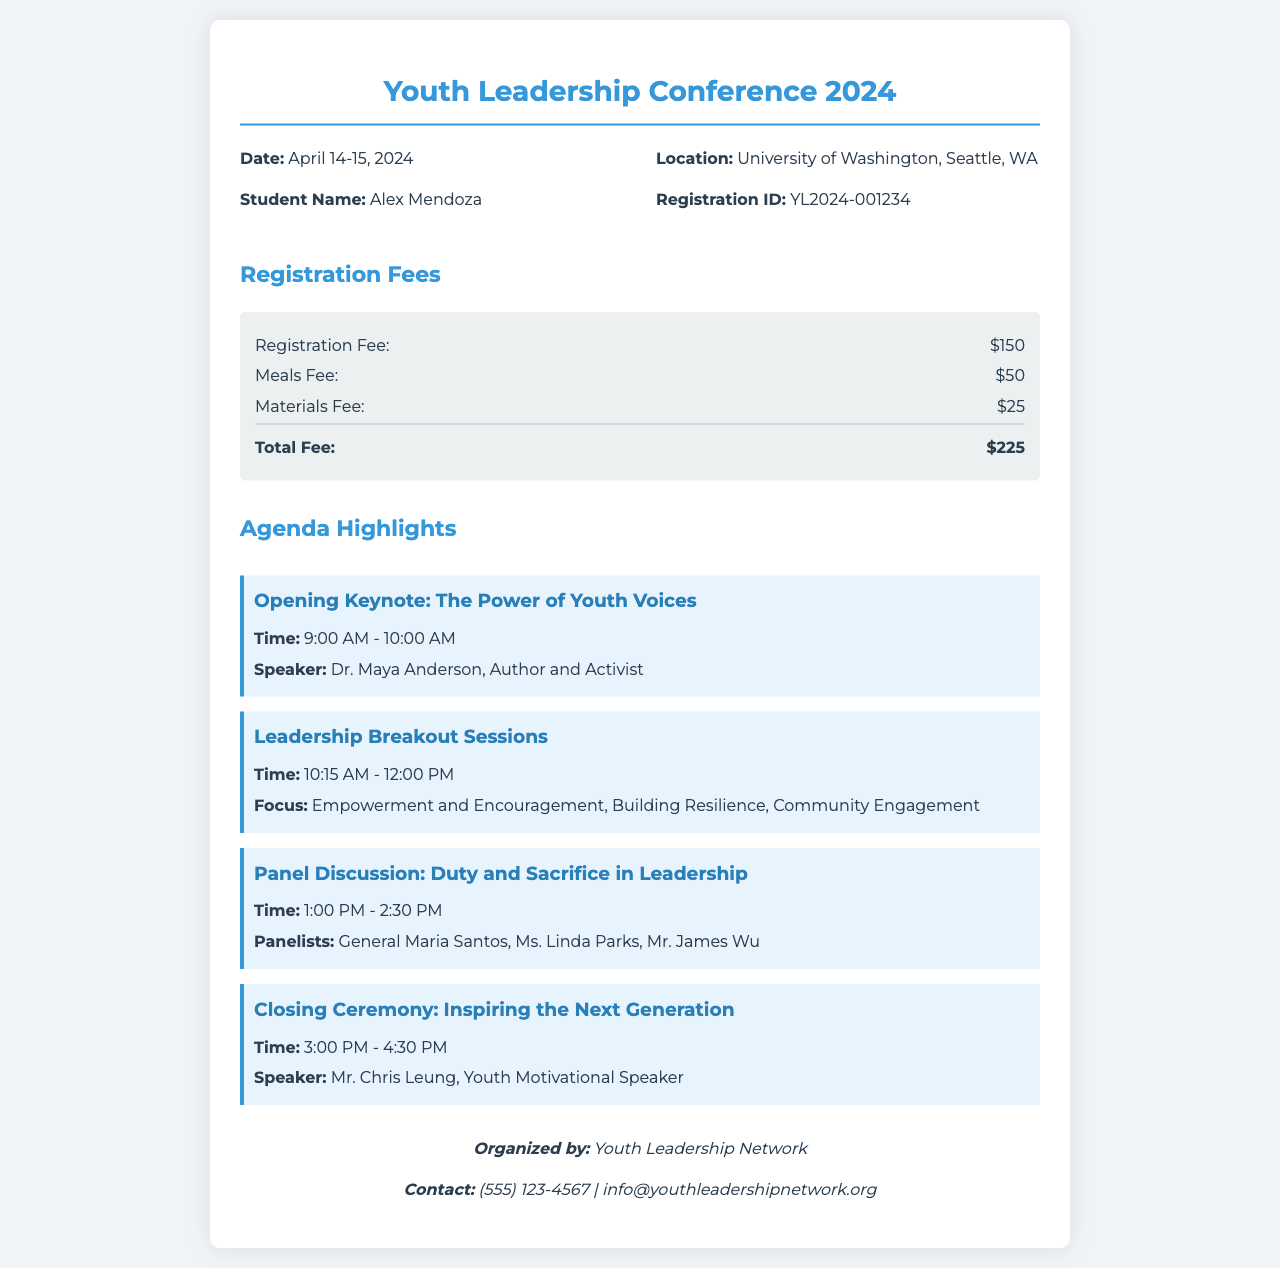What are the dates of the conference? The dates of the conference are explicitly mentioned as April 14-15, 2024.
Answer: April 14-15, 2024 Who is the registered participant? The document states that the registered participant is Alex Mendoza.
Answer: Alex Mendoza What is the total fee for registration? The total fee is provided in the fees section, calculated as the sum of registration, meals, and materials fees.
Answer: $225 Who is the speaker for the opening keynote? The document identifies Dr. Maya Anderson as the speaker for the opening keynote.
Answer: Dr. Maya Anderson What topic is covered in the panel discussion? The panel discussion topic is listed as Duty and Sacrifice in Leadership in the agenda section.
Answer: Duty and Sacrifice in Leadership What is the location of the conference? The conference location is specified in the receipt as University of Washington, Seattle, WA.
Answer: University of Washington, Seattle, WA How many agenda highlights are there? By counting the agenda items listed, we see there are four agenda highlights mentioned.
Answer: Four Who organized the conference? The document states that the conference is organized by Youth Leadership Network.
Answer: Youth Leadership Network What is the time of the closing ceremony? The closing ceremony time is provided as 3:00 PM - 4:30 PM.
Answer: 3:00 PM - 4:30 PM 